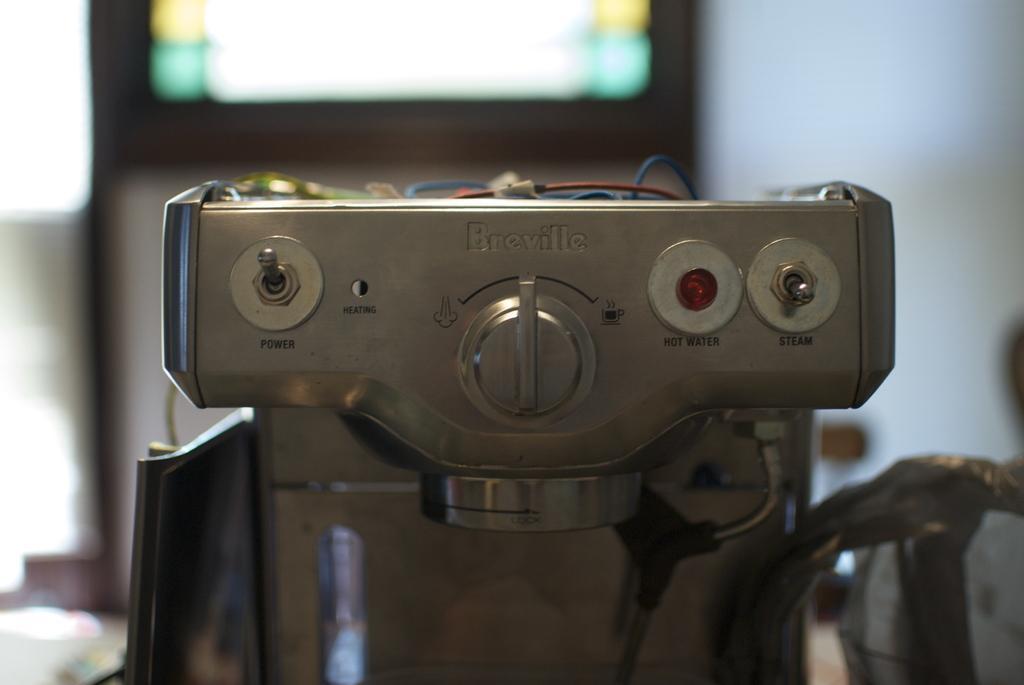Please provide a concise description of this image. In this image I can see there is a coffee machine, in the foreground of the image and it has knobs and there are wires on top of it. The backdrop of the image is blurred. 